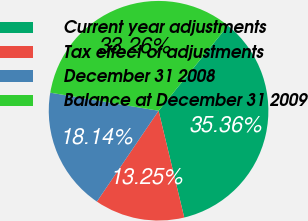Convert chart to OTSL. <chart><loc_0><loc_0><loc_500><loc_500><pie_chart><fcel>Current year adjustments<fcel>Tax effect of adjustments<fcel>December 31 2008<fcel>Balance at December 31 2009<nl><fcel>35.36%<fcel>13.25%<fcel>18.14%<fcel>33.26%<nl></chart> 